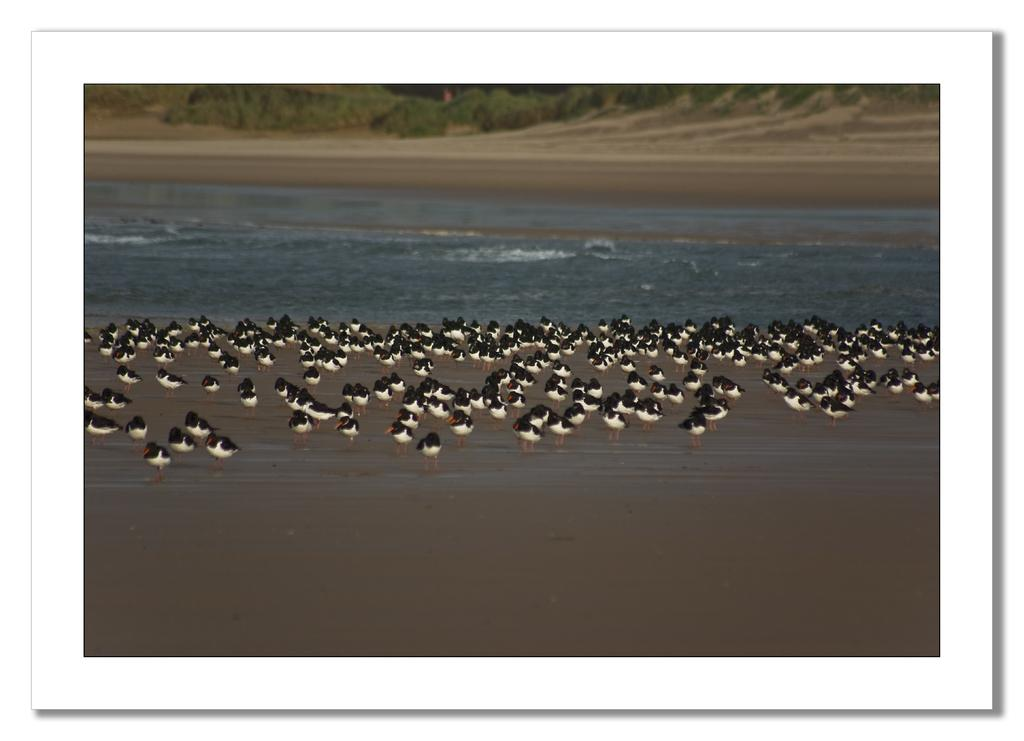What type of animals can be seen on the sand in the image? There are birds on the sand in the image. What other elements can be found in the image besides the birds? There are plants and water visible in the image. What type of chain can be seen connecting the birds in the image? There is no chain present in the image; the birds are not connected. 